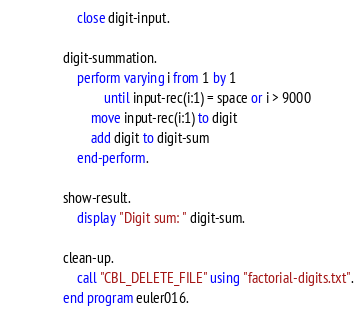Convert code to text. <code><loc_0><loc_0><loc_500><loc_500><_COBOL_>           close digit-input.

       digit-summation.
           perform varying i from 1 by 1
                   until input-rec(i:1) = space or i > 9000
               move input-rec(i:1) to digit
               add digit to digit-sum
           end-perform.

       show-result.
           display "Digit sum: " digit-sum.

       clean-up.
           call "CBL_DELETE_FILE" using "factorial-digits.txt".
       end program euler016.
</code> 